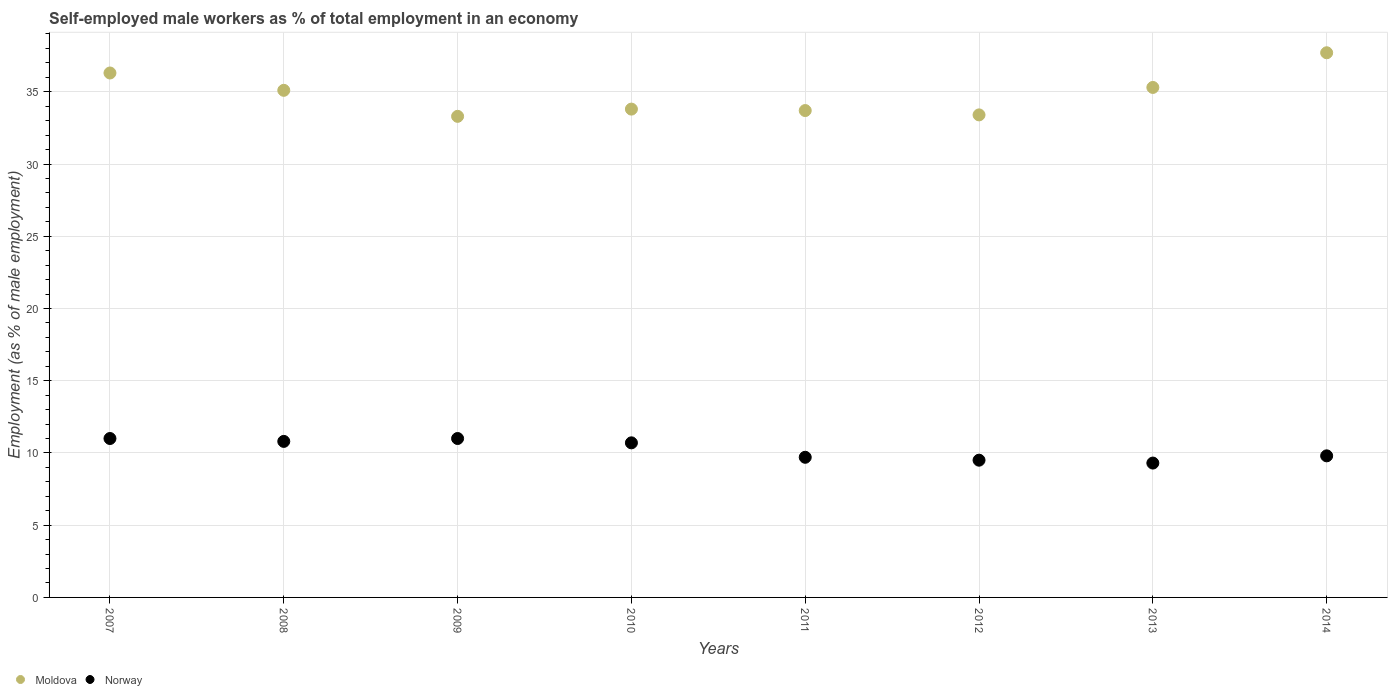Is the number of dotlines equal to the number of legend labels?
Your answer should be very brief. Yes. What is the percentage of self-employed male workers in Norway in 2009?
Keep it short and to the point. 11. Across all years, what is the maximum percentage of self-employed male workers in Moldova?
Provide a short and direct response. 37.7. Across all years, what is the minimum percentage of self-employed male workers in Moldova?
Keep it short and to the point. 33.3. In which year was the percentage of self-employed male workers in Moldova maximum?
Your response must be concise. 2014. In which year was the percentage of self-employed male workers in Moldova minimum?
Keep it short and to the point. 2009. What is the total percentage of self-employed male workers in Moldova in the graph?
Your answer should be compact. 278.6. What is the difference between the percentage of self-employed male workers in Norway in 2009 and that in 2014?
Your answer should be very brief. 1.2. What is the difference between the percentage of self-employed male workers in Norway in 2011 and the percentage of self-employed male workers in Moldova in 2014?
Offer a terse response. -28. What is the average percentage of self-employed male workers in Moldova per year?
Provide a short and direct response. 34.82. In the year 2008, what is the difference between the percentage of self-employed male workers in Norway and percentage of self-employed male workers in Moldova?
Your answer should be very brief. -24.3. In how many years, is the percentage of self-employed male workers in Norway greater than 38 %?
Keep it short and to the point. 0. What is the ratio of the percentage of self-employed male workers in Norway in 2007 to that in 2013?
Offer a terse response. 1.18. What is the difference between the highest and the lowest percentage of self-employed male workers in Moldova?
Provide a short and direct response. 4.4. Is the sum of the percentage of self-employed male workers in Moldova in 2008 and 2010 greater than the maximum percentage of self-employed male workers in Norway across all years?
Offer a very short reply. Yes. Is the percentage of self-employed male workers in Norway strictly less than the percentage of self-employed male workers in Moldova over the years?
Your answer should be compact. Yes. How many dotlines are there?
Keep it short and to the point. 2. Does the graph contain any zero values?
Keep it short and to the point. No. Does the graph contain grids?
Make the answer very short. Yes. How are the legend labels stacked?
Offer a very short reply. Horizontal. What is the title of the graph?
Offer a terse response. Self-employed male workers as % of total employment in an economy. Does "Georgia" appear as one of the legend labels in the graph?
Your response must be concise. No. What is the label or title of the Y-axis?
Give a very brief answer. Employment (as % of male employment). What is the Employment (as % of male employment) in Moldova in 2007?
Your response must be concise. 36.3. What is the Employment (as % of male employment) in Norway in 2007?
Provide a short and direct response. 11. What is the Employment (as % of male employment) of Moldova in 2008?
Keep it short and to the point. 35.1. What is the Employment (as % of male employment) in Norway in 2008?
Provide a succinct answer. 10.8. What is the Employment (as % of male employment) of Moldova in 2009?
Provide a short and direct response. 33.3. What is the Employment (as % of male employment) of Moldova in 2010?
Your answer should be very brief. 33.8. What is the Employment (as % of male employment) of Norway in 2010?
Keep it short and to the point. 10.7. What is the Employment (as % of male employment) in Moldova in 2011?
Make the answer very short. 33.7. What is the Employment (as % of male employment) of Norway in 2011?
Give a very brief answer. 9.7. What is the Employment (as % of male employment) in Moldova in 2012?
Ensure brevity in your answer.  33.4. What is the Employment (as % of male employment) of Moldova in 2013?
Your answer should be very brief. 35.3. What is the Employment (as % of male employment) in Norway in 2013?
Keep it short and to the point. 9.3. What is the Employment (as % of male employment) in Moldova in 2014?
Offer a terse response. 37.7. What is the Employment (as % of male employment) in Norway in 2014?
Keep it short and to the point. 9.8. Across all years, what is the maximum Employment (as % of male employment) of Moldova?
Provide a succinct answer. 37.7. Across all years, what is the maximum Employment (as % of male employment) of Norway?
Your response must be concise. 11. Across all years, what is the minimum Employment (as % of male employment) of Moldova?
Provide a succinct answer. 33.3. Across all years, what is the minimum Employment (as % of male employment) of Norway?
Give a very brief answer. 9.3. What is the total Employment (as % of male employment) of Moldova in the graph?
Make the answer very short. 278.6. What is the total Employment (as % of male employment) in Norway in the graph?
Offer a terse response. 81.8. What is the difference between the Employment (as % of male employment) in Moldova in 2007 and that in 2008?
Your response must be concise. 1.2. What is the difference between the Employment (as % of male employment) of Norway in 2007 and that in 2008?
Your response must be concise. 0.2. What is the difference between the Employment (as % of male employment) in Moldova in 2007 and that in 2009?
Offer a terse response. 3. What is the difference between the Employment (as % of male employment) in Norway in 2007 and that in 2009?
Keep it short and to the point. 0. What is the difference between the Employment (as % of male employment) in Norway in 2007 and that in 2012?
Provide a short and direct response. 1.5. What is the difference between the Employment (as % of male employment) in Norway in 2007 and that in 2013?
Your answer should be compact. 1.7. What is the difference between the Employment (as % of male employment) of Moldova in 2007 and that in 2014?
Your answer should be compact. -1.4. What is the difference between the Employment (as % of male employment) in Moldova in 2008 and that in 2009?
Keep it short and to the point. 1.8. What is the difference between the Employment (as % of male employment) in Norway in 2008 and that in 2009?
Your response must be concise. -0.2. What is the difference between the Employment (as % of male employment) of Moldova in 2008 and that in 2010?
Your answer should be compact. 1.3. What is the difference between the Employment (as % of male employment) of Moldova in 2008 and that in 2011?
Make the answer very short. 1.4. What is the difference between the Employment (as % of male employment) in Moldova in 2008 and that in 2012?
Make the answer very short. 1.7. What is the difference between the Employment (as % of male employment) of Moldova in 2008 and that in 2013?
Give a very brief answer. -0.2. What is the difference between the Employment (as % of male employment) of Norway in 2008 and that in 2013?
Give a very brief answer. 1.5. What is the difference between the Employment (as % of male employment) of Norway in 2008 and that in 2014?
Your answer should be compact. 1. What is the difference between the Employment (as % of male employment) of Moldova in 2009 and that in 2010?
Ensure brevity in your answer.  -0.5. What is the difference between the Employment (as % of male employment) of Moldova in 2009 and that in 2011?
Offer a very short reply. -0.4. What is the difference between the Employment (as % of male employment) in Norway in 2009 and that in 2011?
Ensure brevity in your answer.  1.3. What is the difference between the Employment (as % of male employment) in Moldova in 2009 and that in 2012?
Your answer should be very brief. -0.1. What is the difference between the Employment (as % of male employment) in Norway in 2009 and that in 2012?
Your answer should be very brief. 1.5. What is the difference between the Employment (as % of male employment) in Moldova in 2009 and that in 2013?
Offer a terse response. -2. What is the difference between the Employment (as % of male employment) in Moldova in 2010 and that in 2011?
Your answer should be very brief. 0.1. What is the difference between the Employment (as % of male employment) in Norway in 2010 and that in 2011?
Your response must be concise. 1. What is the difference between the Employment (as % of male employment) in Moldova in 2010 and that in 2012?
Provide a short and direct response. 0.4. What is the difference between the Employment (as % of male employment) of Norway in 2010 and that in 2012?
Offer a very short reply. 1.2. What is the difference between the Employment (as % of male employment) of Moldova in 2010 and that in 2013?
Offer a very short reply. -1.5. What is the difference between the Employment (as % of male employment) in Norway in 2010 and that in 2013?
Keep it short and to the point. 1.4. What is the difference between the Employment (as % of male employment) in Moldova in 2010 and that in 2014?
Your answer should be compact. -3.9. What is the difference between the Employment (as % of male employment) of Norway in 2010 and that in 2014?
Your answer should be compact. 0.9. What is the difference between the Employment (as % of male employment) of Norway in 2011 and that in 2012?
Provide a succinct answer. 0.2. What is the difference between the Employment (as % of male employment) of Moldova in 2011 and that in 2013?
Give a very brief answer. -1.6. What is the difference between the Employment (as % of male employment) in Norway in 2011 and that in 2014?
Offer a terse response. -0.1. What is the difference between the Employment (as % of male employment) of Moldova in 2012 and that in 2013?
Your response must be concise. -1.9. What is the difference between the Employment (as % of male employment) of Norway in 2012 and that in 2013?
Offer a very short reply. 0.2. What is the difference between the Employment (as % of male employment) in Moldova in 2012 and that in 2014?
Your response must be concise. -4.3. What is the difference between the Employment (as % of male employment) of Norway in 2012 and that in 2014?
Offer a very short reply. -0.3. What is the difference between the Employment (as % of male employment) of Moldova in 2007 and the Employment (as % of male employment) of Norway in 2008?
Your answer should be compact. 25.5. What is the difference between the Employment (as % of male employment) of Moldova in 2007 and the Employment (as % of male employment) of Norway in 2009?
Ensure brevity in your answer.  25.3. What is the difference between the Employment (as % of male employment) in Moldova in 2007 and the Employment (as % of male employment) in Norway in 2010?
Give a very brief answer. 25.6. What is the difference between the Employment (as % of male employment) in Moldova in 2007 and the Employment (as % of male employment) in Norway in 2011?
Provide a short and direct response. 26.6. What is the difference between the Employment (as % of male employment) in Moldova in 2007 and the Employment (as % of male employment) in Norway in 2012?
Your response must be concise. 26.8. What is the difference between the Employment (as % of male employment) in Moldova in 2008 and the Employment (as % of male employment) in Norway in 2009?
Give a very brief answer. 24.1. What is the difference between the Employment (as % of male employment) of Moldova in 2008 and the Employment (as % of male employment) of Norway in 2010?
Offer a terse response. 24.4. What is the difference between the Employment (as % of male employment) in Moldova in 2008 and the Employment (as % of male employment) in Norway in 2011?
Your answer should be compact. 25.4. What is the difference between the Employment (as % of male employment) in Moldova in 2008 and the Employment (as % of male employment) in Norway in 2012?
Keep it short and to the point. 25.6. What is the difference between the Employment (as % of male employment) of Moldova in 2008 and the Employment (as % of male employment) of Norway in 2013?
Keep it short and to the point. 25.8. What is the difference between the Employment (as % of male employment) of Moldova in 2008 and the Employment (as % of male employment) of Norway in 2014?
Your response must be concise. 25.3. What is the difference between the Employment (as % of male employment) in Moldova in 2009 and the Employment (as % of male employment) in Norway in 2010?
Make the answer very short. 22.6. What is the difference between the Employment (as % of male employment) in Moldova in 2009 and the Employment (as % of male employment) in Norway in 2011?
Make the answer very short. 23.6. What is the difference between the Employment (as % of male employment) of Moldova in 2009 and the Employment (as % of male employment) of Norway in 2012?
Ensure brevity in your answer.  23.8. What is the difference between the Employment (as % of male employment) of Moldova in 2009 and the Employment (as % of male employment) of Norway in 2014?
Offer a very short reply. 23.5. What is the difference between the Employment (as % of male employment) in Moldova in 2010 and the Employment (as % of male employment) in Norway in 2011?
Offer a terse response. 24.1. What is the difference between the Employment (as % of male employment) of Moldova in 2010 and the Employment (as % of male employment) of Norway in 2012?
Provide a succinct answer. 24.3. What is the difference between the Employment (as % of male employment) of Moldova in 2010 and the Employment (as % of male employment) of Norway in 2013?
Give a very brief answer. 24.5. What is the difference between the Employment (as % of male employment) in Moldova in 2011 and the Employment (as % of male employment) in Norway in 2012?
Ensure brevity in your answer.  24.2. What is the difference between the Employment (as % of male employment) in Moldova in 2011 and the Employment (as % of male employment) in Norway in 2013?
Ensure brevity in your answer.  24.4. What is the difference between the Employment (as % of male employment) of Moldova in 2011 and the Employment (as % of male employment) of Norway in 2014?
Offer a very short reply. 23.9. What is the difference between the Employment (as % of male employment) in Moldova in 2012 and the Employment (as % of male employment) in Norway in 2013?
Make the answer very short. 24.1. What is the difference between the Employment (as % of male employment) of Moldova in 2012 and the Employment (as % of male employment) of Norway in 2014?
Keep it short and to the point. 23.6. What is the average Employment (as % of male employment) in Moldova per year?
Offer a very short reply. 34.83. What is the average Employment (as % of male employment) in Norway per year?
Ensure brevity in your answer.  10.22. In the year 2007, what is the difference between the Employment (as % of male employment) in Moldova and Employment (as % of male employment) in Norway?
Your answer should be very brief. 25.3. In the year 2008, what is the difference between the Employment (as % of male employment) in Moldova and Employment (as % of male employment) in Norway?
Provide a succinct answer. 24.3. In the year 2009, what is the difference between the Employment (as % of male employment) of Moldova and Employment (as % of male employment) of Norway?
Offer a terse response. 22.3. In the year 2010, what is the difference between the Employment (as % of male employment) in Moldova and Employment (as % of male employment) in Norway?
Provide a succinct answer. 23.1. In the year 2012, what is the difference between the Employment (as % of male employment) in Moldova and Employment (as % of male employment) in Norway?
Your response must be concise. 23.9. In the year 2014, what is the difference between the Employment (as % of male employment) in Moldova and Employment (as % of male employment) in Norway?
Offer a terse response. 27.9. What is the ratio of the Employment (as % of male employment) of Moldova in 2007 to that in 2008?
Give a very brief answer. 1.03. What is the ratio of the Employment (as % of male employment) of Norway in 2007 to that in 2008?
Ensure brevity in your answer.  1.02. What is the ratio of the Employment (as % of male employment) of Moldova in 2007 to that in 2009?
Your answer should be compact. 1.09. What is the ratio of the Employment (as % of male employment) in Norway in 2007 to that in 2009?
Give a very brief answer. 1. What is the ratio of the Employment (as % of male employment) in Moldova in 2007 to that in 2010?
Provide a short and direct response. 1.07. What is the ratio of the Employment (as % of male employment) in Norway in 2007 to that in 2010?
Your answer should be very brief. 1.03. What is the ratio of the Employment (as % of male employment) of Moldova in 2007 to that in 2011?
Provide a succinct answer. 1.08. What is the ratio of the Employment (as % of male employment) in Norway in 2007 to that in 2011?
Keep it short and to the point. 1.13. What is the ratio of the Employment (as % of male employment) of Moldova in 2007 to that in 2012?
Provide a short and direct response. 1.09. What is the ratio of the Employment (as % of male employment) of Norway in 2007 to that in 2012?
Your answer should be compact. 1.16. What is the ratio of the Employment (as % of male employment) of Moldova in 2007 to that in 2013?
Give a very brief answer. 1.03. What is the ratio of the Employment (as % of male employment) of Norway in 2007 to that in 2013?
Offer a terse response. 1.18. What is the ratio of the Employment (as % of male employment) in Moldova in 2007 to that in 2014?
Offer a terse response. 0.96. What is the ratio of the Employment (as % of male employment) of Norway in 2007 to that in 2014?
Provide a succinct answer. 1.12. What is the ratio of the Employment (as % of male employment) of Moldova in 2008 to that in 2009?
Give a very brief answer. 1.05. What is the ratio of the Employment (as % of male employment) of Norway in 2008 to that in 2009?
Your response must be concise. 0.98. What is the ratio of the Employment (as % of male employment) of Moldova in 2008 to that in 2010?
Offer a terse response. 1.04. What is the ratio of the Employment (as % of male employment) of Norway in 2008 to that in 2010?
Your answer should be very brief. 1.01. What is the ratio of the Employment (as % of male employment) of Moldova in 2008 to that in 2011?
Keep it short and to the point. 1.04. What is the ratio of the Employment (as % of male employment) in Norway in 2008 to that in 2011?
Offer a very short reply. 1.11. What is the ratio of the Employment (as % of male employment) in Moldova in 2008 to that in 2012?
Provide a succinct answer. 1.05. What is the ratio of the Employment (as % of male employment) of Norway in 2008 to that in 2012?
Your response must be concise. 1.14. What is the ratio of the Employment (as % of male employment) in Moldova in 2008 to that in 2013?
Ensure brevity in your answer.  0.99. What is the ratio of the Employment (as % of male employment) of Norway in 2008 to that in 2013?
Keep it short and to the point. 1.16. What is the ratio of the Employment (as % of male employment) in Moldova in 2008 to that in 2014?
Ensure brevity in your answer.  0.93. What is the ratio of the Employment (as % of male employment) of Norway in 2008 to that in 2014?
Provide a short and direct response. 1.1. What is the ratio of the Employment (as % of male employment) in Moldova in 2009 to that in 2010?
Provide a succinct answer. 0.99. What is the ratio of the Employment (as % of male employment) in Norway in 2009 to that in 2010?
Make the answer very short. 1.03. What is the ratio of the Employment (as % of male employment) of Moldova in 2009 to that in 2011?
Your response must be concise. 0.99. What is the ratio of the Employment (as % of male employment) of Norway in 2009 to that in 2011?
Offer a very short reply. 1.13. What is the ratio of the Employment (as % of male employment) in Norway in 2009 to that in 2012?
Offer a terse response. 1.16. What is the ratio of the Employment (as % of male employment) of Moldova in 2009 to that in 2013?
Ensure brevity in your answer.  0.94. What is the ratio of the Employment (as % of male employment) in Norway in 2009 to that in 2013?
Your response must be concise. 1.18. What is the ratio of the Employment (as % of male employment) of Moldova in 2009 to that in 2014?
Make the answer very short. 0.88. What is the ratio of the Employment (as % of male employment) in Norway in 2009 to that in 2014?
Provide a short and direct response. 1.12. What is the ratio of the Employment (as % of male employment) of Norway in 2010 to that in 2011?
Your answer should be very brief. 1.1. What is the ratio of the Employment (as % of male employment) in Norway in 2010 to that in 2012?
Give a very brief answer. 1.13. What is the ratio of the Employment (as % of male employment) of Moldova in 2010 to that in 2013?
Provide a succinct answer. 0.96. What is the ratio of the Employment (as % of male employment) in Norway in 2010 to that in 2013?
Keep it short and to the point. 1.15. What is the ratio of the Employment (as % of male employment) in Moldova in 2010 to that in 2014?
Ensure brevity in your answer.  0.9. What is the ratio of the Employment (as % of male employment) in Norway in 2010 to that in 2014?
Offer a very short reply. 1.09. What is the ratio of the Employment (as % of male employment) in Norway in 2011 to that in 2012?
Your response must be concise. 1.02. What is the ratio of the Employment (as % of male employment) in Moldova in 2011 to that in 2013?
Offer a terse response. 0.95. What is the ratio of the Employment (as % of male employment) in Norway in 2011 to that in 2013?
Ensure brevity in your answer.  1.04. What is the ratio of the Employment (as % of male employment) of Moldova in 2011 to that in 2014?
Your answer should be very brief. 0.89. What is the ratio of the Employment (as % of male employment) of Moldova in 2012 to that in 2013?
Offer a very short reply. 0.95. What is the ratio of the Employment (as % of male employment) in Norway in 2012 to that in 2013?
Provide a succinct answer. 1.02. What is the ratio of the Employment (as % of male employment) of Moldova in 2012 to that in 2014?
Provide a short and direct response. 0.89. What is the ratio of the Employment (as % of male employment) in Norway in 2012 to that in 2014?
Your answer should be compact. 0.97. What is the ratio of the Employment (as % of male employment) in Moldova in 2013 to that in 2014?
Your answer should be very brief. 0.94. What is the ratio of the Employment (as % of male employment) in Norway in 2013 to that in 2014?
Keep it short and to the point. 0.95. What is the difference between the highest and the second highest Employment (as % of male employment) in Norway?
Your answer should be very brief. 0. 